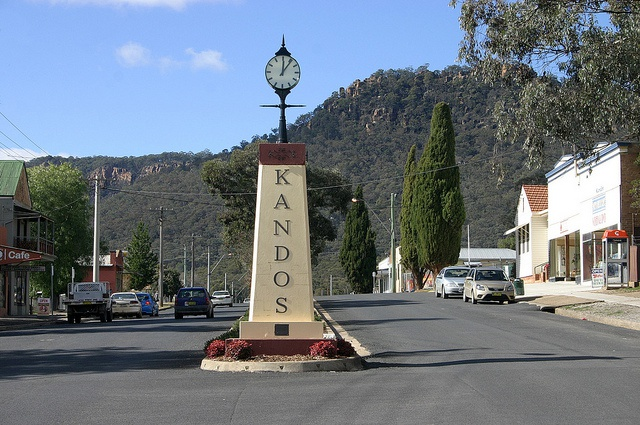Describe the objects in this image and their specific colors. I can see truck in lightblue, black, and gray tones, car in lightblue, black, darkgray, gray, and lightgray tones, car in lightblue, black, navy, gray, and purple tones, clock in lightblue, darkgray, gray, black, and blue tones, and car in lightblue, lightgray, darkgray, gray, and black tones in this image. 